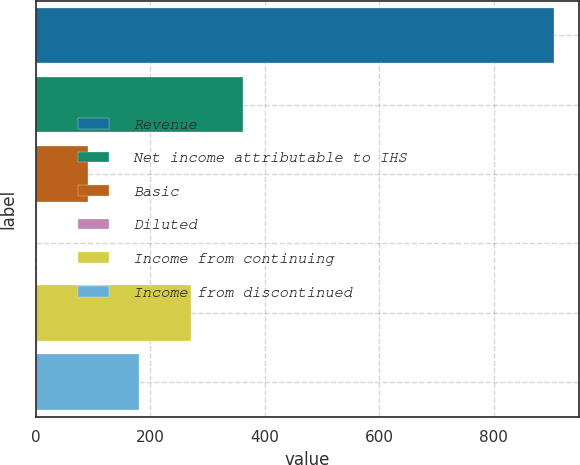Convert chart to OTSL. <chart><loc_0><loc_0><loc_500><loc_500><bar_chart><fcel>Revenue<fcel>Net income attributable to IHS<fcel>Basic<fcel>Diluted<fcel>Income from continuing<fcel>Income from discontinued<nl><fcel>904.7<fcel>362.08<fcel>90.78<fcel>0.35<fcel>271.65<fcel>181.22<nl></chart> 